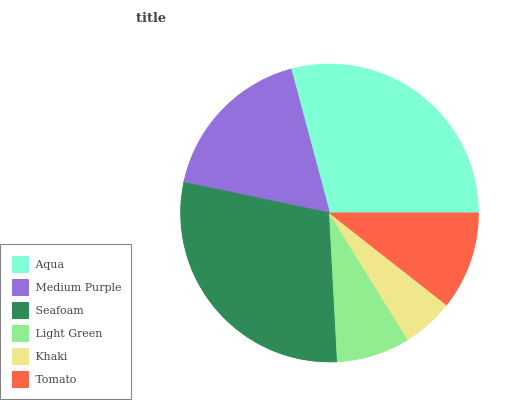Is Khaki the minimum?
Answer yes or no. Yes. Is Aqua the maximum?
Answer yes or no. Yes. Is Medium Purple the minimum?
Answer yes or no. No. Is Medium Purple the maximum?
Answer yes or no. No. Is Aqua greater than Medium Purple?
Answer yes or no. Yes. Is Medium Purple less than Aqua?
Answer yes or no. Yes. Is Medium Purple greater than Aqua?
Answer yes or no. No. Is Aqua less than Medium Purple?
Answer yes or no. No. Is Medium Purple the high median?
Answer yes or no. Yes. Is Tomato the low median?
Answer yes or no. Yes. Is Khaki the high median?
Answer yes or no. No. Is Medium Purple the low median?
Answer yes or no. No. 